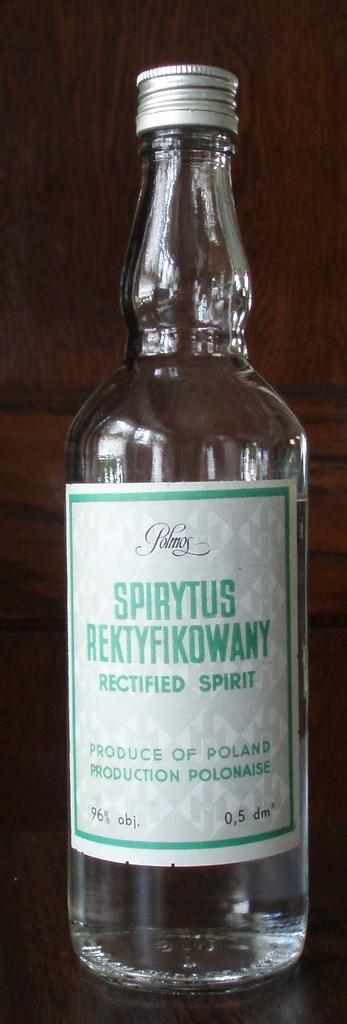<image>
Summarize the visual content of the image. a clear bottle of spirits produced in poland 